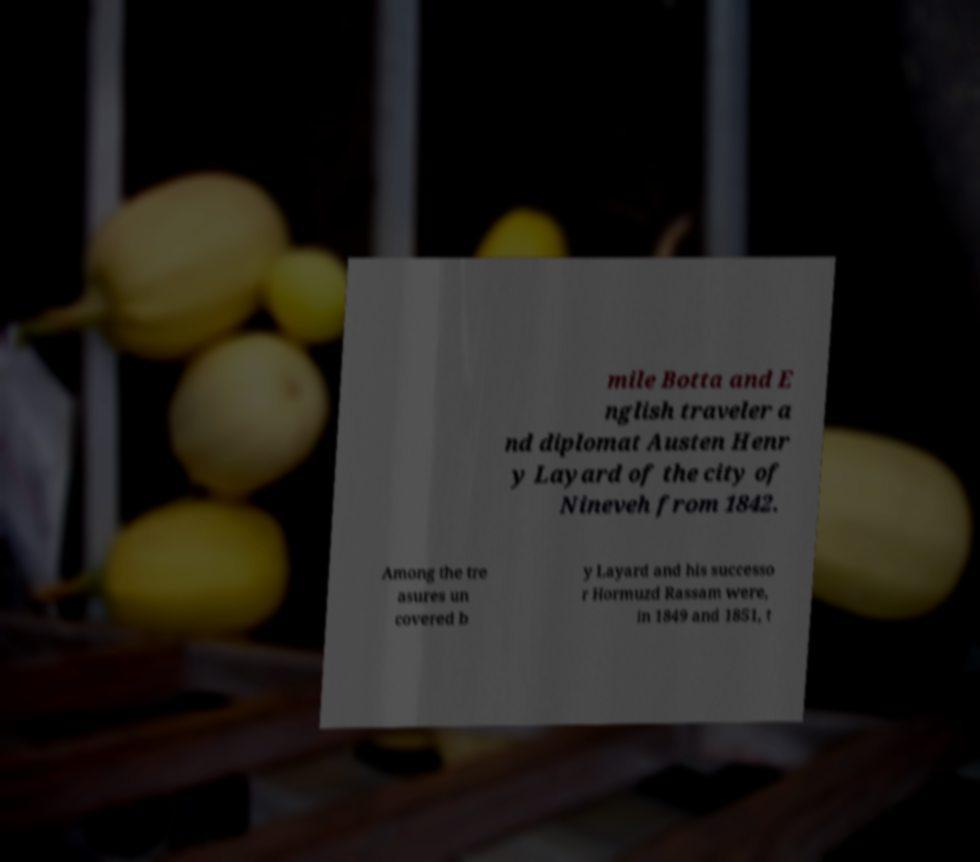Please identify and transcribe the text found in this image. mile Botta and E nglish traveler a nd diplomat Austen Henr y Layard of the city of Nineveh from 1842. Among the tre asures un covered b y Layard and his successo r Hormuzd Rassam were, in 1849 and 1851, t 